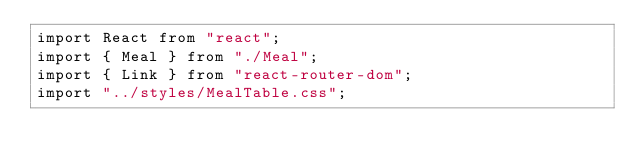Convert code to text. <code><loc_0><loc_0><loc_500><loc_500><_JavaScript_>import React from "react";
import { Meal } from "./Meal";
import { Link } from "react-router-dom";
import "../styles/MealTable.css";
</code> 